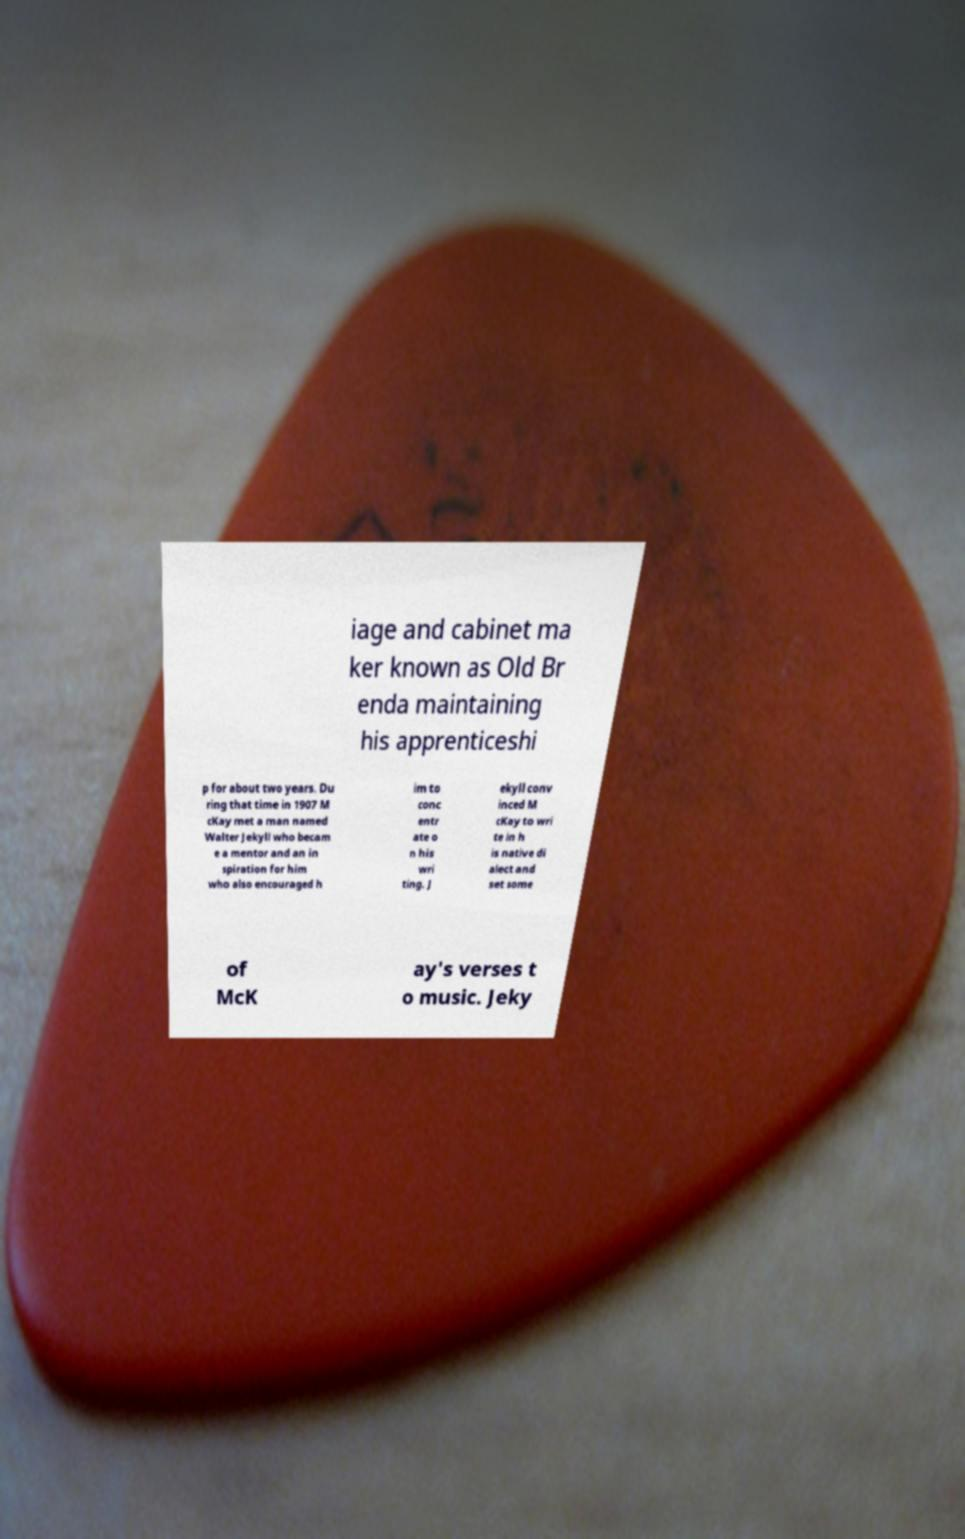Can you read and provide the text displayed in the image?This photo seems to have some interesting text. Can you extract and type it out for me? iage and cabinet ma ker known as Old Br enda maintaining his apprenticeshi p for about two years. Du ring that time in 1907 M cKay met a man named Walter Jekyll who becam e a mentor and an in spiration for him who also encouraged h im to conc entr ate o n his wri ting. J ekyll conv inced M cKay to wri te in h is native di alect and set some of McK ay's verses t o music. Jeky 